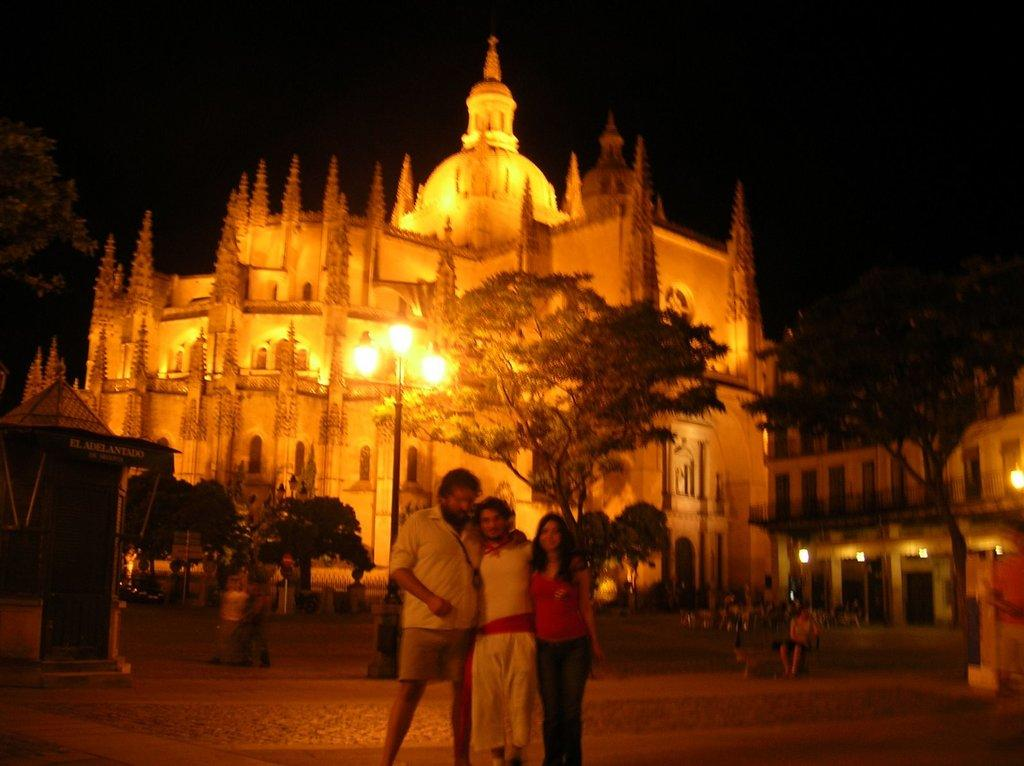Who or what can be seen in the image? There are people in the image. What can be observed in the image that provides illumination? There are lights in the image. What type of natural elements are present in the image? There are trees in the image. What type of man-made structures are visible in the image? There are buildings in the image. How would you describe the overall lighting conditions in the image? The background of the image is dark. What type of fiction is being distributed in the image? There is no reference to fiction or distribution in the image; it features people, lights, trees, buildings, and a dark background. 